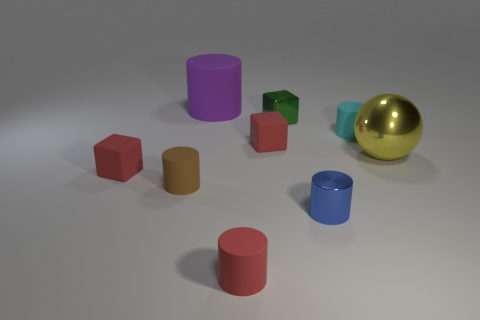What shape is the tiny shiny thing that is in front of the tiny matte cylinder that is to the left of the rubber object that is in front of the tiny blue metal cylinder?
Ensure brevity in your answer.  Cylinder. Are there more brown matte things that are behind the yellow ball than tiny green blocks?
Offer a very short reply. No. Are there any other large objects of the same shape as the brown object?
Ensure brevity in your answer.  Yes. Does the blue cylinder have the same material as the small cylinder that is on the left side of the purple cylinder?
Your answer should be compact. No. The metal block has what color?
Keep it short and to the point. Green. What number of tiny rubber cylinders are in front of the matte cube that is in front of the tiny red block that is on the right side of the purple matte object?
Keep it short and to the point. 2. Are there any small brown cylinders behind the purple object?
Offer a terse response. No. How many cylinders have the same material as the small brown object?
Your answer should be compact. 3. How many objects are either tiny cyan matte cylinders or red rubber objects?
Your answer should be compact. 4. Are there any green blocks?
Offer a terse response. Yes. 